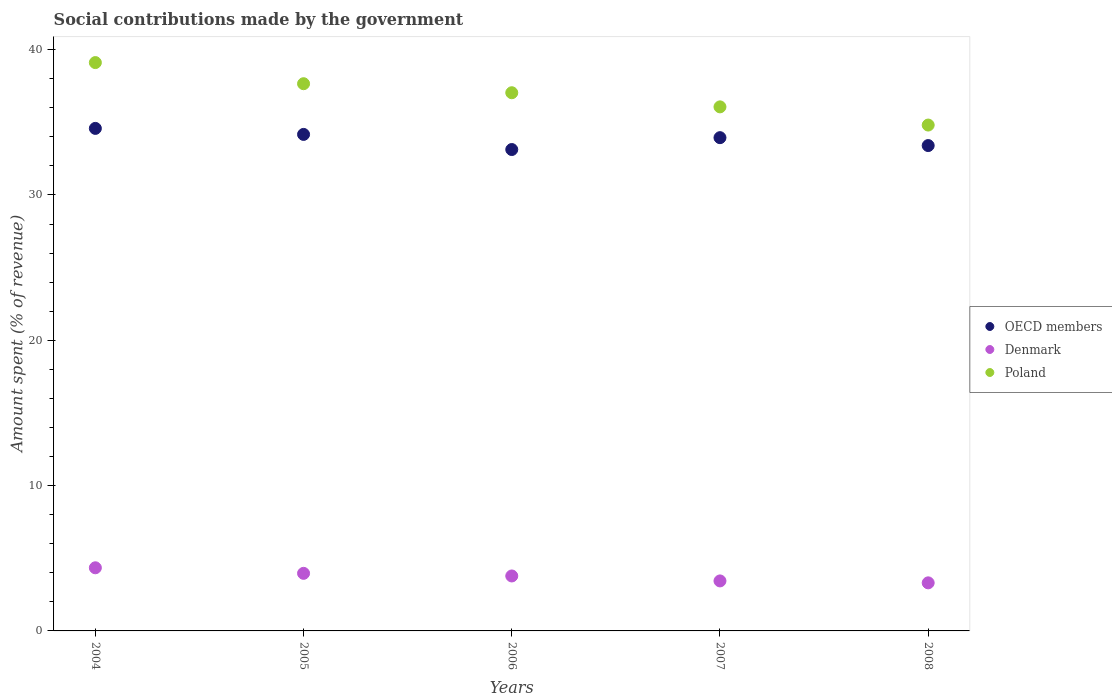What is the amount spent (in %) on social contributions in Poland in 2007?
Give a very brief answer. 36.06. Across all years, what is the maximum amount spent (in %) on social contributions in Poland?
Your answer should be very brief. 39.11. Across all years, what is the minimum amount spent (in %) on social contributions in Poland?
Offer a very short reply. 34.81. What is the total amount spent (in %) on social contributions in Denmark in the graph?
Your answer should be compact. 18.84. What is the difference between the amount spent (in %) on social contributions in OECD members in 2004 and that in 2005?
Give a very brief answer. 0.41. What is the difference between the amount spent (in %) on social contributions in Poland in 2007 and the amount spent (in %) on social contributions in Denmark in 2008?
Ensure brevity in your answer.  32.75. What is the average amount spent (in %) on social contributions in OECD members per year?
Your response must be concise. 33.84. In the year 2007, what is the difference between the amount spent (in %) on social contributions in Poland and amount spent (in %) on social contributions in Denmark?
Make the answer very short. 32.62. In how many years, is the amount spent (in %) on social contributions in OECD members greater than 28 %?
Your answer should be very brief. 5. What is the ratio of the amount spent (in %) on social contributions in Poland in 2006 to that in 2008?
Your answer should be compact. 1.06. Is the amount spent (in %) on social contributions in OECD members in 2005 less than that in 2008?
Provide a succinct answer. No. Is the difference between the amount spent (in %) on social contributions in Poland in 2004 and 2006 greater than the difference between the amount spent (in %) on social contributions in Denmark in 2004 and 2006?
Give a very brief answer. Yes. What is the difference between the highest and the second highest amount spent (in %) on social contributions in OECD members?
Make the answer very short. 0.41. What is the difference between the highest and the lowest amount spent (in %) on social contributions in Denmark?
Provide a succinct answer. 1.04. In how many years, is the amount spent (in %) on social contributions in Denmark greater than the average amount spent (in %) on social contributions in Denmark taken over all years?
Provide a short and direct response. 3. Is the sum of the amount spent (in %) on social contributions in Poland in 2005 and 2006 greater than the maximum amount spent (in %) on social contributions in OECD members across all years?
Your response must be concise. Yes. Is it the case that in every year, the sum of the amount spent (in %) on social contributions in OECD members and amount spent (in %) on social contributions in Denmark  is greater than the amount spent (in %) on social contributions in Poland?
Your answer should be very brief. No. Does the amount spent (in %) on social contributions in OECD members monotonically increase over the years?
Ensure brevity in your answer.  No. Is the amount spent (in %) on social contributions in Denmark strictly greater than the amount spent (in %) on social contributions in OECD members over the years?
Your response must be concise. No. Is the amount spent (in %) on social contributions in OECD members strictly less than the amount spent (in %) on social contributions in Poland over the years?
Provide a short and direct response. Yes. What is the difference between two consecutive major ticks on the Y-axis?
Your answer should be very brief. 10. Where does the legend appear in the graph?
Provide a short and direct response. Center right. How many legend labels are there?
Offer a very short reply. 3. What is the title of the graph?
Your answer should be very brief. Social contributions made by the government. Does "Norway" appear as one of the legend labels in the graph?
Provide a succinct answer. No. What is the label or title of the X-axis?
Provide a succinct answer. Years. What is the label or title of the Y-axis?
Your answer should be very brief. Amount spent (% of revenue). What is the Amount spent (% of revenue) of OECD members in 2004?
Keep it short and to the point. 34.58. What is the Amount spent (% of revenue) in Denmark in 2004?
Offer a very short reply. 4.34. What is the Amount spent (% of revenue) of Poland in 2004?
Make the answer very short. 39.11. What is the Amount spent (% of revenue) of OECD members in 2005?
Offer a very short reply. 34.17. What is the Amount spent (% of revenue) in Denmark in 2005?
Ensure brevity in your answer.  3.96. What is the Amount spent (% of revenue) in Poland in 2005?
Make the answer very short. 37.66. What is the Amount spent (% of revenue) of OECD members in 2006?
Give a very brief answer. 33.13. What is the Amount spent (% of revenue) of Denmark in 2006?
Your answer should be compact. 3.78. What is the Amount spent (% of revenue) in Poland in 2006?
Provide a short and direct response. 37.03. What is the Amount spent (% of revenue) in OECD members in 2007?
Offer a terse response. 33.94. What is the Amount spent (% of revenue) in Denmark in 2007?
Your answer should be compact. 3.44. What is the Amount spent (% of revenue) of Poland in 2007?
Offer a very short reply. 36.06. What is the Amount spent (% of revenue) of OECD members in 2008?
Provide a short and direct response. 33.4. What is the Amount spent (% of revenue) in Denmark in 2008?
Make the answer very short. 3.31. What is the Amount spent (% of revenue) of Poland in 2008?
Provide a short and direct response. 34.81. Across all years, what is the maximum Amount spent (% of revenue) in OECD members?
Keep it short and to the point. 34.58. Across all years, what is the maximum Amount spent (% of revenue) in Denmark?
Offer a terse response. 4.34. Across all years, what is the maximum Amount spent (% of revenue) of Poland?
Offer a terse response. 39.11. Across all years, what is the minimum Amount spent (% of revenue) in OECD members?
Ensure brevity in your answer.  33.13. Across all years, what is the minimum Amount spent (% of revenue) of Denmark?
Make the answer very short. 3.31. Across all years, what is the minimum Amount spent (% of revenue) of Poland?
Your answer should be compact. 34.81. What is the total Amount spent (% of revenue) of OECD members in the graph?
Keep it short and to the point. 169.22. What is the total Amount spent (% of revenue) in Denmark in the graph?
Keep it short and to the point. 18.84. What is the total Amount spent (% of revenue) of Poland in the graph?
Offer a terse response. 184.67. What is the difference between the Amount spent (% of revenue) of OECD members in 2004 and that in 2005?
Provide a succinct answer. 0.41. What is the difference between the Amount spent (% of revenue) of Denmark in 2004 and that in 2005?
Ensure brevity in your answer.  0.38. What is the difference between the Amount spent (% of revenue) of Poland in 2004 and that in 2005?
Provide a succinct answer. 1.45. What is the difference between the Amount spent (% of revenue) of OECD members in 2004 and that in 2006?
Your answer should be compact. 1.45. What is the difference between the Amount spent (% of revenue) of Denmark in 2004 and that in 2006?
Keep it short and to the point. 0.56. What is the difference between the Amount spent (% of revenue) in Poland in 2004 and that in 2006?
Keep it short and to the point. 2.07. What is the difference between the Amount spent (% of revenue) in OECD members in 2004 and that in 2007?
Provide a short and direct response. 0.64. What is the difference between the Amount spent (% of revenue) of Denmark in 2004 and that in 2007?
Keep it short and to the point. 0.9. What is the difference between the Amount spent (% of revenue) of Poland in 2004 and that in 2007?
Keep it short and to the point. 3.05. What is the difference between the Amount spent (% of revenue) in OECD members in 2004 and that in 2008?
Offer a very short reply. 1.18. What is the difference between the Amount spent (% of revenue) of Denmark in 2004 and that in 2008?
Give a very brief answer. 1.04. What is the difference between the Amount spent (% of revenue) of Poland in 2004 and that in 2008?
Keep it short and to the point. 4.3. What is the difference between the Amount spent (% of revenue) of OECD members in 2005 and that in 2006?
Make the answer very short. 1.04. What is the difference between the Amount spent (% of revenue) of Denmark in 2005 and that in 2006?
Offer a very short reply. 0.18. What is the difference between the Amount spent (% of revenue) in Poland in 2005 and that in 2006?
Ensure brevity in your answer.  0.62. What is the difference between the Amount spent (% of revenue) in OECD members in 2005 and that in 2007?
Provide a short and direct response. 0.22. What is the difference between the Amount spent (% of revenue) of Denmark in 2005 and that in 2007?
Ensure brevity in your answer.  0.52. What is the difference between the Amount spent (% of revenue) of Poland in 2005 and that in 2007?
Offer a terse response. 1.59. What is the difference between the Amount spent (% of revenue) in OECD members in 2005 and that in 2008?
Your answer should be very brief. 0.77. What is the difference between the Amount spent (% of revenue) in Denmark in 2005 and that in 2008?
Provide a succinct answer. 0.65. What is the difference between the Amount spent (% of revenue) of Poland in 2005 and that in 2008?
Provide a short and direct response. 2.84. What is the difference between the Amount spent (% of revenue) of OECD members in 2006 and that in 2007?
Provide a short and direct response. -0.82. What is the difference between the Amount spent (% of revenue) in Denmark in 2006 and that in 2007?
Ensure brevity in your answer.  0.34. What is the difference between the Amount spent (% of revenue) of Poland in 2006 and that in 2007?
Provide a short and direct response. 0.97. What is the difference between the Amount spent (% of revenue) of OECD members in 2006 and that in 2008?
Ensure brevity in your answer.  -0.27. What is the difference between the Amount spent (% of revenue) in Denmark in 2006 and that in 2008?
Make the answer very short. 0.47. What is the difference between the Amount spent (% of revenue) in Poland in 2006 and that in 2008?
Ensure brevity in your answer.  2.22. What is the difference between the Amount spent (% of revenue) of OECD members in 2007 and that in 2008?
Ensure brevity in your answer.  0.54. What is the difference between the Amount spent (% of revenue) of Denmark in 2007 and that in 2008?
Ensure brevity in your answer.  0.13. What is the difference between the Amount spent (% of revenue) in Poland in 2007 and that in 2008?
Give a very brief answer. 1.25. What is the difference between the Amount spent (% of revenue) in OECD members in 2004 and the Amount spent (% of revenue) in Denmark in 2005?
Make the answer very short. 30.62. What is the difference between the Amount spent (% of revenue) in OECD members in 2004 and the Amount spent (% of revenue) in Poland in 2005?
Keep it short and to the point. -3.07. What is the difference between the Amount spent (% of revenue) in Denmark in 2004 and the Amount spent (% of revenue) in Poland in 2005?
Offer a terse response. -33.31. What is the difference between the Amount spent (% of revenue) of OECD members in 2004 and the Amount spent (% of revenue) of Denmark in 2006?
Ensure brevity in your answer.  30.8. What is the difference between the Amount spent (% of revenue) in OECD members in 2004 and the Amount spent (% of revenue) in Poland in 2006?
Provide a succinct answer. -2.45. What is the difference between the Amount spent (% of revenue) of Denmark in 2004 and the Amount spent (% of revenue) of Poland in 2006?
Your response must be concise. -32.69. What is the difference between the Amount spent (% of revenue) of OECD members in 2004 and the Amount spent (% of revenue) of Denmark in 2007?
Provide a succinct answer. 31.14. What is the difference between the Amount spent (% of revenue) in OECD members in 2004 and the Amount spent (% of revenue) in Poland in 2007?
Provide a succinct answer. -1.48. What is the difference between the Amount spent (% of revenue) in Denmark in 2004 and the Amount spent (% of revenue) in Poland in 2007?
Your answer should be compact. -31.72. What is the difference between the Amount spent (% of revenue) in OECD members in 2004 and the Amount spent (% of revenue) in Denmark in 2008?
Offer a terse response. 31.27. What is the difference between the Amount spent (% of revenue) in OECD members in 2004 and the Amount spent (% of revenue) in Poland in 2008?
Keep it short and to the point. -0.23. What is the difference between the Amount spent (% of revenue) in Denmark in 2004 and the Amount spent (% of revenue) in Poland in 2008?
Provide a succinct answer. -30.47. What is the difference between the Amount spent (% of revenue) in OECD members in 2005 and the Amount spent (% of revenue) in Denmark in 2006?
Provide a succinct answer. 30.39. What is the difference between the Amount spent (% of revenue) of OECD members in 2005 and the Amount spent (% of revenue) of Poland in 2006?
Offer a very short reply. -2.87. What is the difference between the Amount spent (% of revenue) of Denmark in 2005 and the Amount spent (% of revenue) of Poland in 2006?
Give a very brief answer. -33.07. What is the difference between the Amount spent (% of revenue) in OECD members in 2005 and the Amount spent (% of revenue) in Denmark in 2007?
Keep it short and to the point. 30.73. What is the difference between the Amount spent (% of revenue) of OECD members in 2005 and the Amount spent (% of revenue) of Poland in 2007?
Your response must be concise. -1.9. What is the difference between the Amount spent (% of revenue) of Denmark in 2005 and the Amount spent (% of revenue) of Poland in 2007?
Give a very brief answer. -32.1. What is the difference between the Amount spent (% of revenue) in OECD members in 2005 and the Amount spent (% of revenue) in Denmark in 2008?
Your response must be concise. 30.86. What is the difference between the Amount spent (% of revenue) of OECD members in 2005 and the Amount spent (% of revenue) of Poland in 2008?
Your answer should be compact. -0.64. What is the difference between the Amount spent (% of revenue) in Denmark in 2005 and the Amount spent (% of revenue) in Poland in 2008?
Your answer should be compact. -30.85. What is the difference between the Amount spent (% of revenue) of OECD members in 2006 and the Amount spent (% of revenue) of Denmark in 2007?
Provide a short and direct response. 29.69. What is the difference between the Amount spent (% of revenue) of OECD members in 2006 and the Amount spent (% of revenue) of Poland in 2007?
Ensure brevity in your answer.  -2.94. What is the difference between the Amount spent (% of revenue) of Denmark in 2006 and the Amount spent (% of revenue) of Poland in 2007?
Provide a succinct answer. -32.28. What is the difference between the Amount spent (% of revenue) of OECD members in 2006 and the Amount spent (% of revenue) of Denmark in 2008?
Keep it short and to the point. 29.82. What is the difference between the Amount spent (% of revenue) of OECD members in 2006 and the Amount spent (% of revenue) of Poland in 2008?
Ensure brevity in your answer.  -1.68. What is the difference between the Amount spent (% of revenue) of Denmark in 2006 and the Amount spent (% of revenue) of Poland in 2008?
Your answer should be compact. -31.03. What is the difference between the Amount spent (% of revenue) in OECD members in 2007 and the Amount spent (% of revenue) in Denmark in 2008?
Provide a succinct answer. 30.64. What is the difference between the Amount spent (% of revenue) in OECD members in 2007 and the Amount spent (% of revenue) in Poland in 2008?
Keep it short and to the point. -0.87. What is the difference between the Amount spent (% of revenue) in Denmark in 2007 and the Amount spent (% of revenue) in Poland in 2008?
Your response must be concise. -31.37. What is the average Amount spent (% of revenue) of OECD members per year?
Provide a short and direct response. 33.84. What is the average Amount spent (% of revenue) in Denmark per year?
Keep it short and to the point. 3.77. What is the average Amount spent (% of revenue) of Poland per year?
Give a very brief answer. 36.93. In the year 2004, what is the difference between the Amount spent (% of revenue) in OECD members and Amount spent (% of revenue) in Denmark?
Give a very brief answer. 30.24. In the year 2004, what is the difference between the Amount spent (% of revenue) in OECD members and Amount spent (% of revenue) in Poland?
Make the answer very short. -4.53. In the year 2004, what is the difference between the Amount spent (% of revenue) in Denmark and Amount spent (% of revenue) in Poland?
Provide a short and direct response. -34.76. In the year 2005, what is the difference between the Amount spent (% of revenue) of OECD members and Amount spent (% of revenue) of Denmark?
Provide a short and direct response. 30.2. In the year 2005, what is the difference between the Amount spent (% of revenue) of OECD members and Amount spent (% of revenue) of Poland?
Offer a terse response. -3.49. In the year 2005, what is the difference between the Amount spent (% of revenue) of Denmark and Amount spent (% of revenue) of Poland?
Keep it short and to the point. -33.69. In the year 2006, what is the difference between the Amount spent (% of revenue) in OECD members and Amount spent (% of revenue) in Denmark?
Offer a terse response. 29.34. In the year 2006, what is the difference between the Amount spent (% of revenue) of OECD members and Amount spent (% of revenue) of Poland?
Offer a very short reply. -3.91. In the year 2006, what is the difference between the Amount spent (% of revenue) of Denmark and Amount spent (% of revenue) of Poland?
Your response must be concise. -33.25. In the year 2007, what is the difference between the Amount spent (% of revenue) in OECD members and Amount spent (% of revenue) in Denmark?
Keep it short and to the point. 30.5. In the year 2007, what is the difference between the Amount spent (% of revenue) of OECD members and Amount spent (% of revenue) of Poland?
Your answer should be compact. -2.12. In the year 2007, what is the difference between the Amount spent (% of revenue) of Denmark and Amount spent (% of revenue) of Poland?
Keep it short and to the point. -32.62. In the year 2008, what is the difference between the Amount spent (% of revenue) in OECD members and Amount spent (% of revenue) in Denmark?
Your answer should be compact. 30.09. In the year 2008, what is the difference between the Amount spent (% of revenue) in OECD members and Amount spent (% of revenue) in Poland?
Your answer should be compact. -1.41. In the year 2008, what is the difference between the Amount spent (% of revenue) of Denmark and Amount spent (% of revenue) of Poland?
Give a very brief answer. -31.5. What is the ratio of the Amount spent (% of revenue) of OECD members in 2004 to that in 2005?
Offer a terse response. 1.01. What is the ratio of the Amount spent (% of revenue) of Denmark in 2004 to that in 2005?
Offer a terse response. 1.1. What is the ratio of the Amount spent (% of revenue) in Poland in 2004 to that in 2005?
Keep it short and to the point. 1.04. What is the ratio of the Amount spent (% of revenue) of OECD members in 2004 to that in 2006?
Provide a short and direct response. 1.04. What is the ratio of the Amount spent (% of revenue) of Denmark in 2004 to that in 2006?
Give a very brief answer. 1.15. What is the ratio of the Amount spent (% of revenue) of Poland in 2004 to that in 2006?
Make the answer very short. 1.06. What is the ratio of the Amount spent (% of revenue) in OECD members in 2004 to that in 2007?
Ensure brevity in your answer.  1.02. What is the ratio of the Amount spent (% of revenue) in Denmark in 2004 to that in 2007?
Offer a very short reply. 1.26. What is the ratio of the Amount spent (% of revenue) of Poland in 2004 to that in 2007?
Give a very brief answer. 1.08. What is the ratio of the Amount spent (% of revenue) in OECD members in 2004 to that in 2008?
Your answer should be compact. 1.04. What is the ratio of the Amount spent (% of revenue) of Denmark in 2004 to that in 2008?
Your answer should be very brief. 1.31. What is the ratio of the Amount spent (% of revenue) in Poland in 2004 to that in 2008?
Give a very brief answer. 1.12. What is the ratio of the Amount spent (% of revenue) in OECD members in 2005 to that in 2006?
Your answer should be compact. 1.03. What is the ratio of the Amount spent (% of revenue) of Denmark in 2005 to that in 2006?
Ensure brevity in your answer.  1.05. What is the ratio of the Amount spent (% of revenue) in Poland in 2005 to that in 2006?
Your answer should be very brief. 1.02. What is the ratio of the Amount spent (% of revenue) of OECD members in 2005 to that in 2007?
Give a very brief answer. 1.01. What is the ratio of the Amount spent (% of revenue) in Denmark in 2005 to that in 2007?
Make the answer very short. 1.15. What is the ratio of the Amount spent (% of revenue) in Poland in 2005 to that in 2007?
Make the answer very short. 1.04. What is the ratio of the Amount spent (% of revenue) in OECD members in 2005 to that in 2008?
Ensure brevity in your answer.  1.02. What is the ratio of the Amount spent (% of revenue) in Denmark in 2005 to that in 2008?
Offer a very short reply. 1.2. What is the ratio of the Amount spent (% of revenue) in Poland in 2005 to that in 2008?
Your response must be concise. 1.08. What is the ratio of the Amount spent (% of revenue) in OECD members in 2006 to that in 2007?
Offer a terse response. 0.98. What is the ratio of the Amount spent (% of revenue) in Denmark in 2006 to that in 2007?
Give a very brief answer. 1.1. What is the ratio of the Amount spent (% of revenue) of Poland in 2006 to that in 2007?
Offer a terse response. 1.03. What is the ratio of the Amount spent (% of revenue) in OECD members in 2006 to that in 2008?
Your answer should be very brief. 0.99. What is the ratio of the Amount spent (% of revenue) of Denmark in 2006 to that in 2008?
Offer a terse response. 1.14. What is the ratio of the Amount spent (% of revenue) of Poland in 2006 to that in 2008?
Offer a terse response. 1.06. What is the ratio of the Amount spent (% of revenue) of OECD members in 2007 to that in 2008?
Keep it short and to the point. 1.02. What is the ratio of the Amount spent (% of revenue) in Poland in 2007 to that in 2008?
Make the answer very short. 1.04. What is the difference between the highest and the second highest Amount spent (% of revenue) in OECD members?
Your response must be concise. 0.41. What is the difference between the highest and the second highest Amount spent (% of revenue) of Denmark?
Offer a terse response. 0.38. What is the difference between the highest and the second highest Amount spent (% of revenue) in Poland?
Offer a terse response. 1.45. What is the difference between the highest and the lowest Amount spent (% of revenue) in OECD members?
Offer a terse response. 1.45. What is the difference between the highest and the lowest Amount spent (% of revenue) of Denmark?
Provide a short and direct response. 1.04. What is the difference between the highest and the lowest Amount spent (% of revenue) of Poland?
Offer a very short reply. 4.3. 